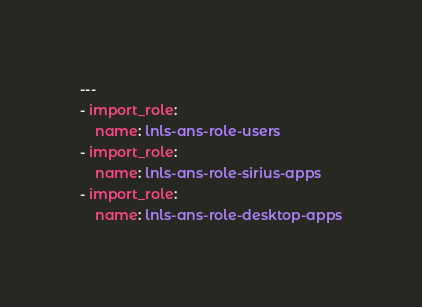Convert code to text. <code><loc_0><loc_0><loc_500><loc_500><_YAML_>---
- import_role:
    name: lnls-ans-role-users
- import_role:
    name: lnls-ans-role-sirius-apps
- import_role:
    name: lnls-ans-role-desktop-apps
</code> 